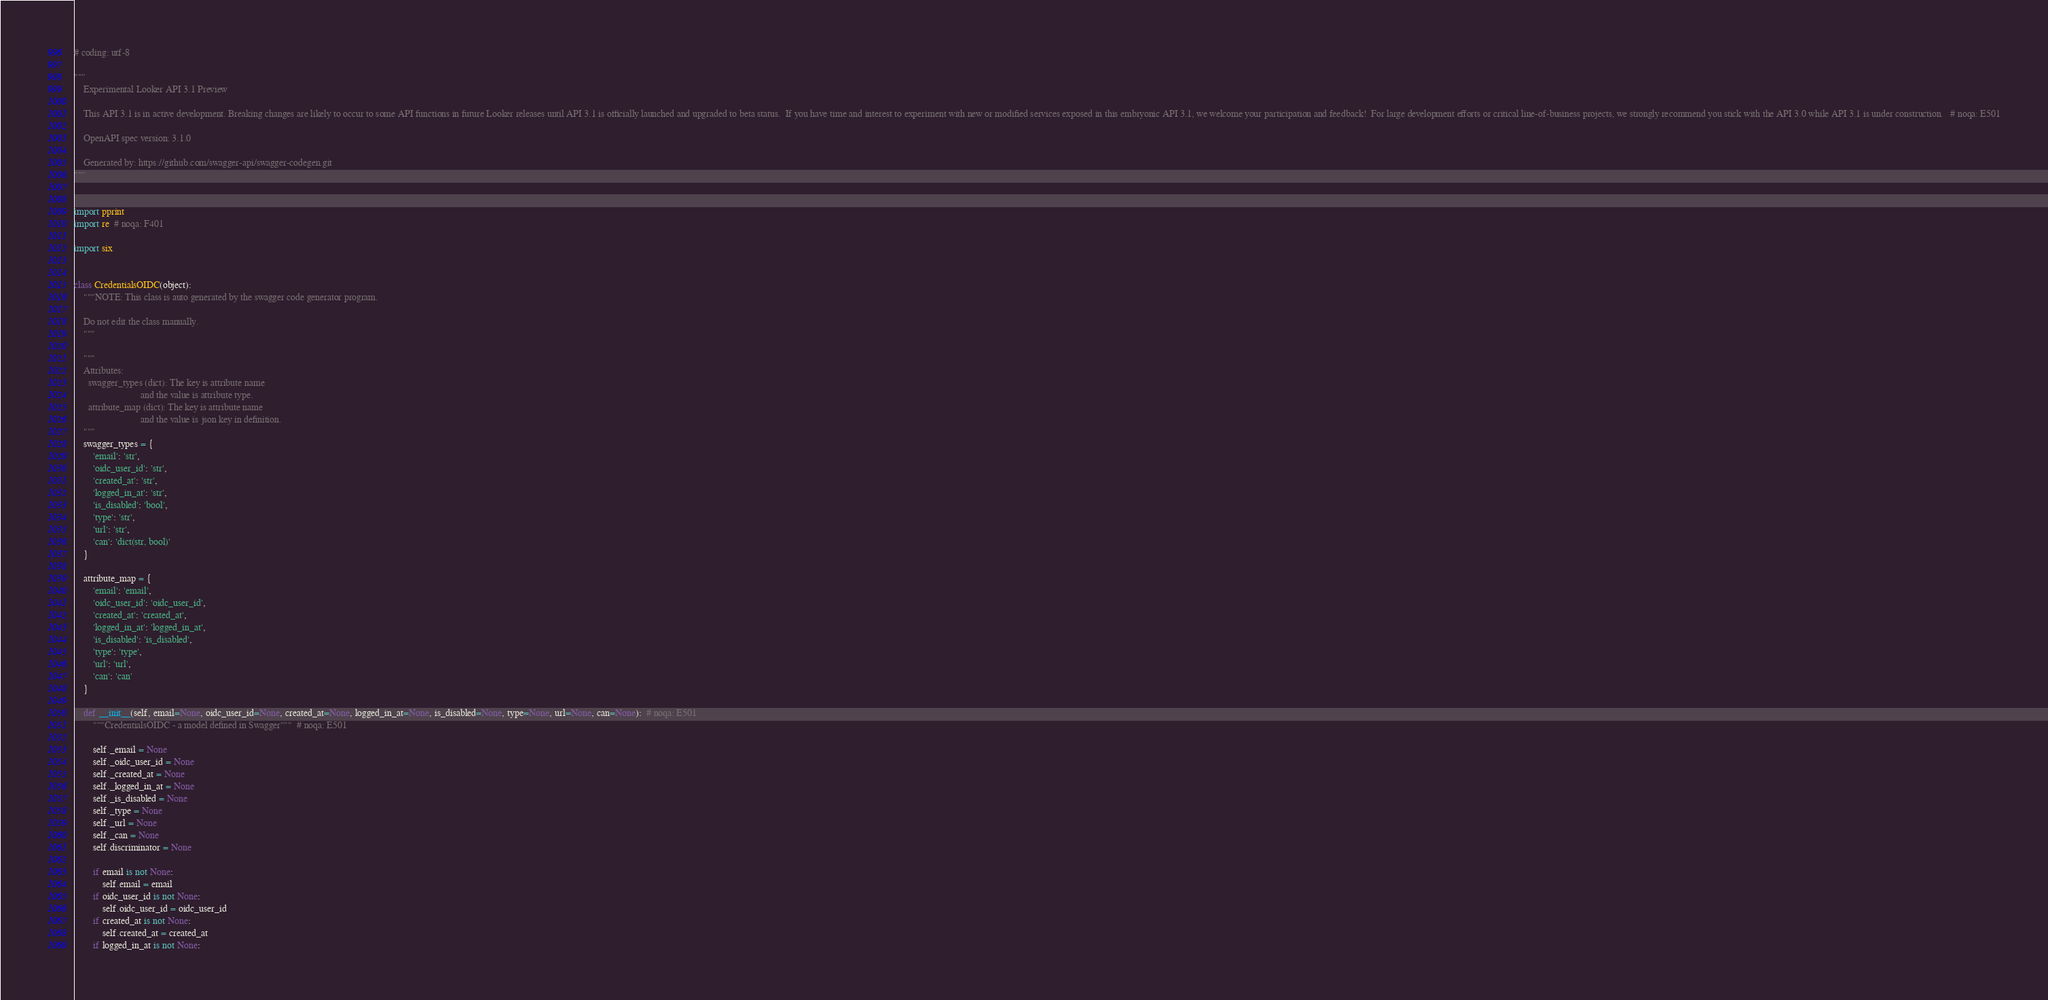Convert code to text. <code><loc_0><loc_0><loc_500><loc_500><_Python_># coding: utf-8

"""
    Experimental Looker API 3.1 Preview

    This API 3.1 is in active development. Breaking changes are likely to occur to some API functions in future Looker releases until API 3.1 is officially launched and upgraded to beta status.  If you have time and interest to experiment with new or modified services exposed in this embryonic API 3.1, we welcome your participation and feedback!  For large development efforts or critical line-of-business projects, we strongly recommend you stick with the API 3.0 while API 3.1 is under construction.   # noqa: E501

    OpenAPI spec version: 3.1.0
    
    Generated by: https://github.com/swagger-api/swagger-codegen.git
"""


import pprint
import re  # noqa: F401

import six


class CredentialsOIDC(object):
    """NOTE: This class is auto generated by the swagger code generator program.

    Do not edit the class manually.
    """

    """
    Attributes:
      swagger_types (dict): The key is attribute name
                            and the value is attribute type.
      attribute_map (dict): The key is attribute name
                            and the value is json key in definition.
    """
    swagger_types = {
        'email': 'str',
        'oidc_user_id': 'str',
        'created_at': 'str',
        'logged_in_at': 'str',
        'is_disabled': 'bool',
        'type': 'str',
        'url': 'str',
        'can': 'dict(str, bool)'
    }

    attribute_map = {
        'email': 'email',
        'oidc_user_id': 'oidc_user_id',
        'created_at': 'created_at',
        'logged_in_at': 'logged_in_at',
        'is_disabled': 'is_disabled',
        'type': 'type',
        'url': 'url',
        'can': 'can'
    }

    def __init__(self, email=None, oidc_user_id=None, created_at=None, logged_in_at=None, is_disabled=None, type=None, url=None, can=None):  # noqa: E501
        """CredentialsOIDC - a model defined in Swagger"""  # noqa: E501

        self._email = None
        self._oidc_user_id = None
        self._created_at = None
        self._logged_in_at = None
        self._is_disabled = None
        self._type = None
        self._url = None
        self._can = None
        self.discriminator = None

        if email is not None:
            self.email = email
        if oidc_user_id is not None:
            self.oidc_user_id = oidc_user_id
        if created_at is not None:
            self.created_at = created_at
        if logged_in_at is not None:</code> 